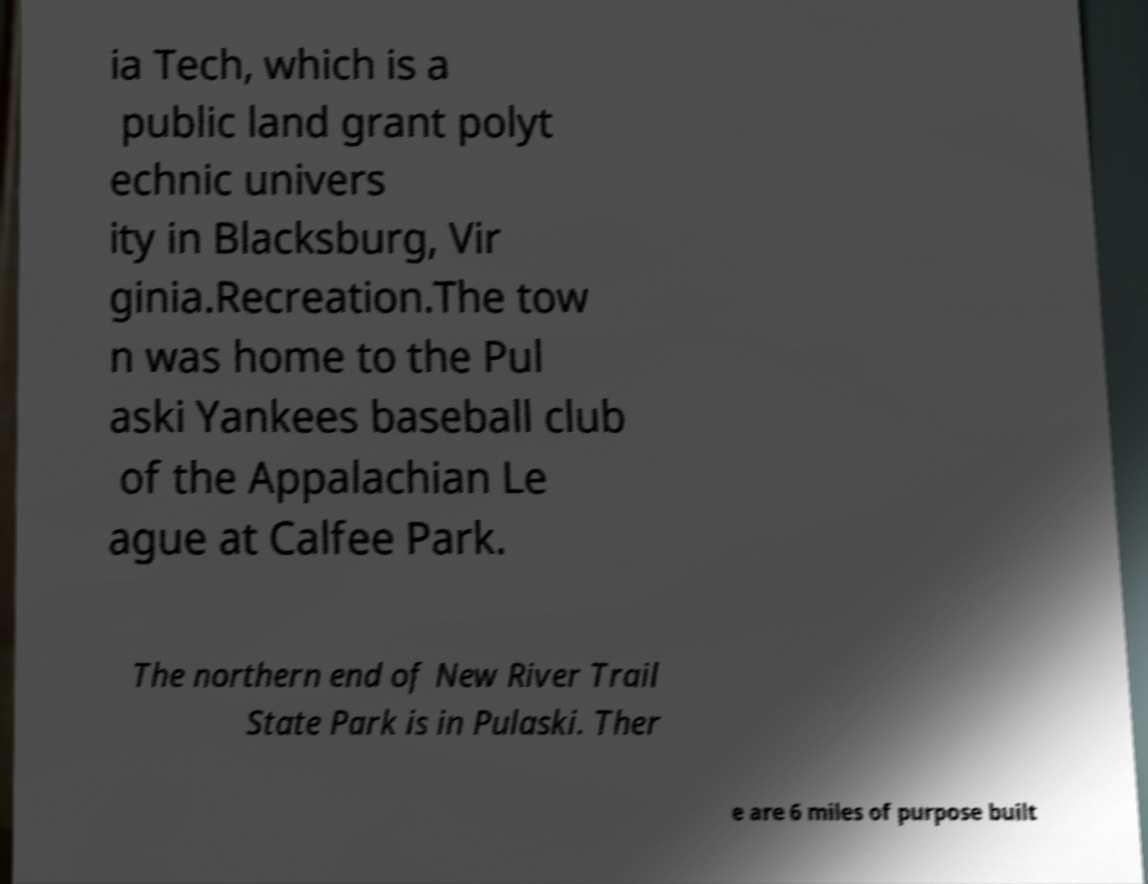I need the written content from this picture converted into text. Can you do that? ia Tech, which is a public land grant polyt echnic univers ity in Blacksburg, Vir ginia.Recreation.The tow n was home to the Pul aski Yankees baseball club of the Appalachian Le ague at Calfee Park. The northern end of New River Trail State Park is in Pulaski. Ther e are 6 miles of purpose built 